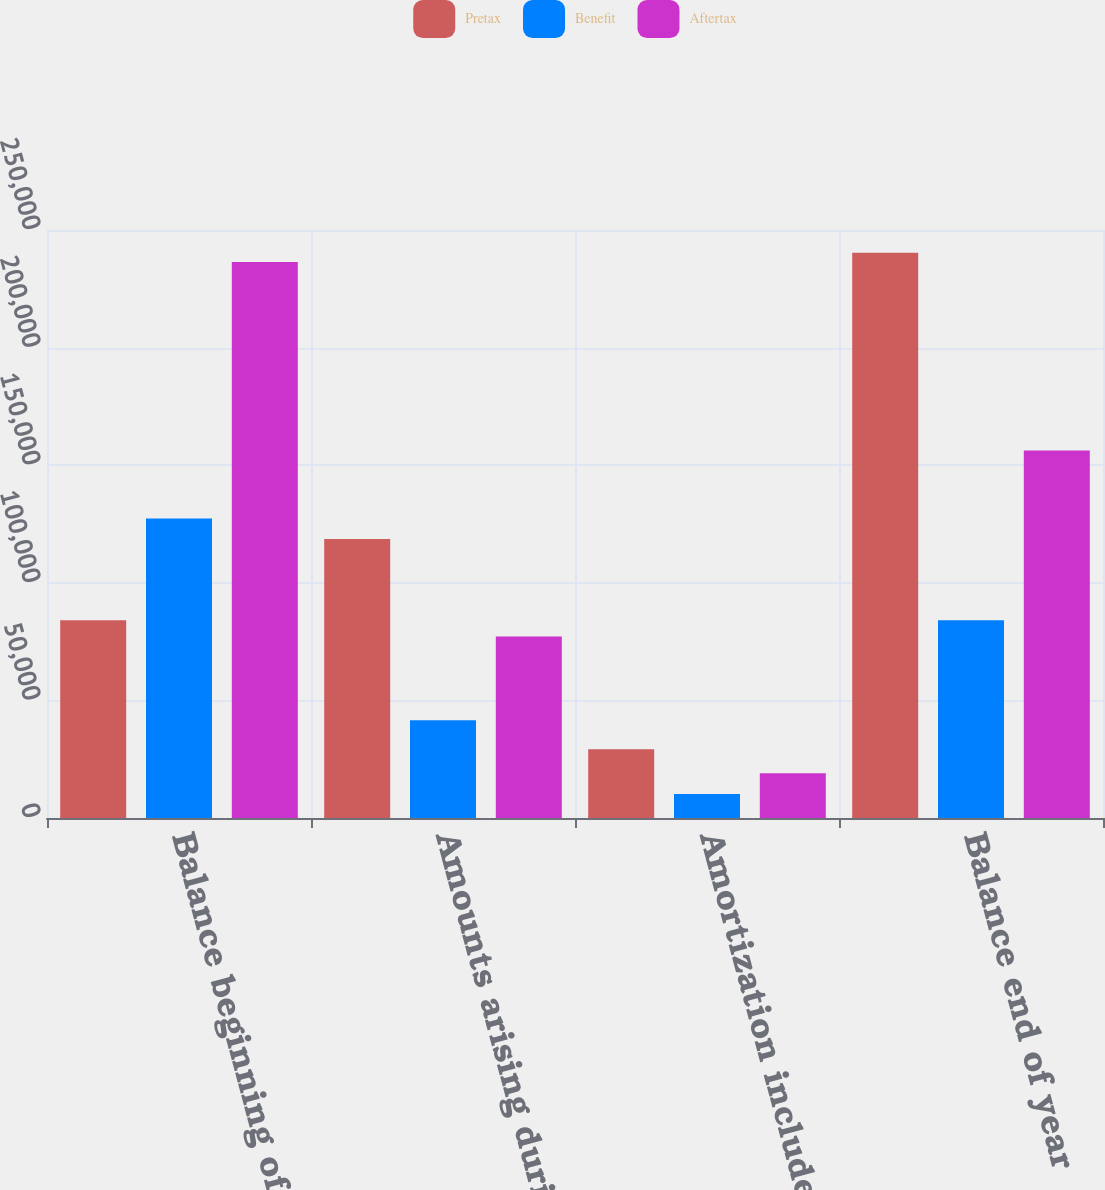Convert chart. <chart><loc_0><loc_0><loc_500><loc_500><stacked_bar_chart><ecel><fcel>Balance beginning of year<fcel>Amounts arising during the<fcel>Amortization included in net<fcel>Balance end of year<nl><fcel>Pretax<fcel>84122<fcel>118666<fcel>29194<fcel>240345<nl><fcel>Benefit<fcel>127292<fcel>41532<fcel>10218<fcel>84122<nl><fcel>Aftertax<fcel>236399<fcel>77134<fcel>18976<fcel>156223<nl></chart> 